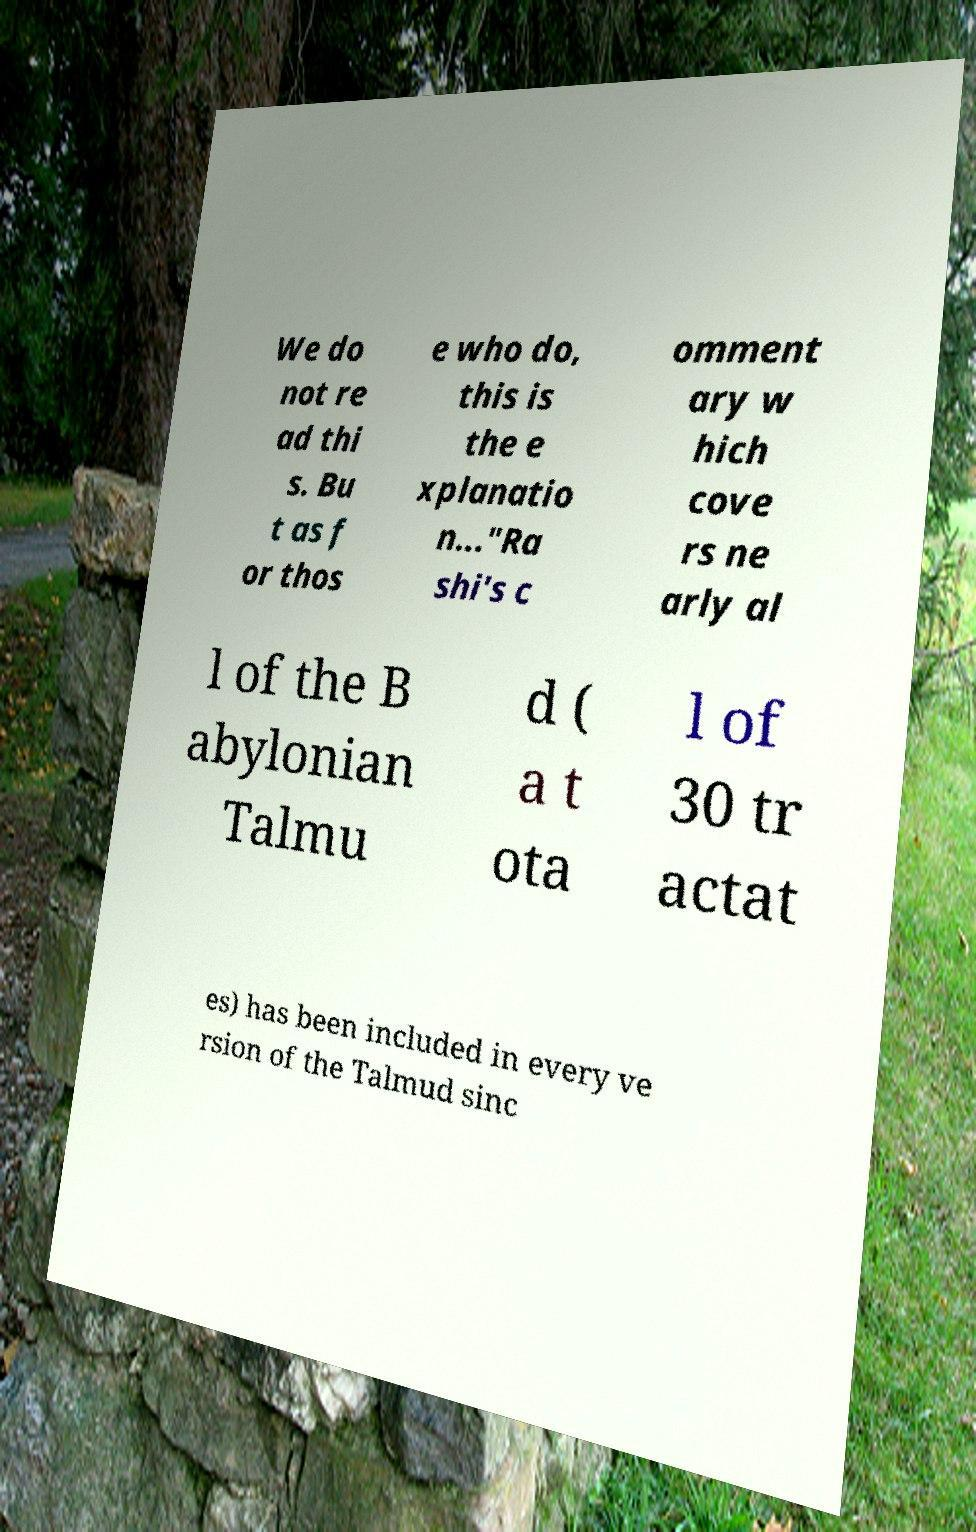I need the written content from this picture converted into text. Can you do that? We do not re ad thi s. Bu t as f or thos e who do, this is the e xplanatio n..."Ra shi's c omment ary w hich cove rs ne arly al l of the B abylonian Talmu d ( a t ota l of 30 tr actat es) has been included in every ve rsion of the Talmud sinc 